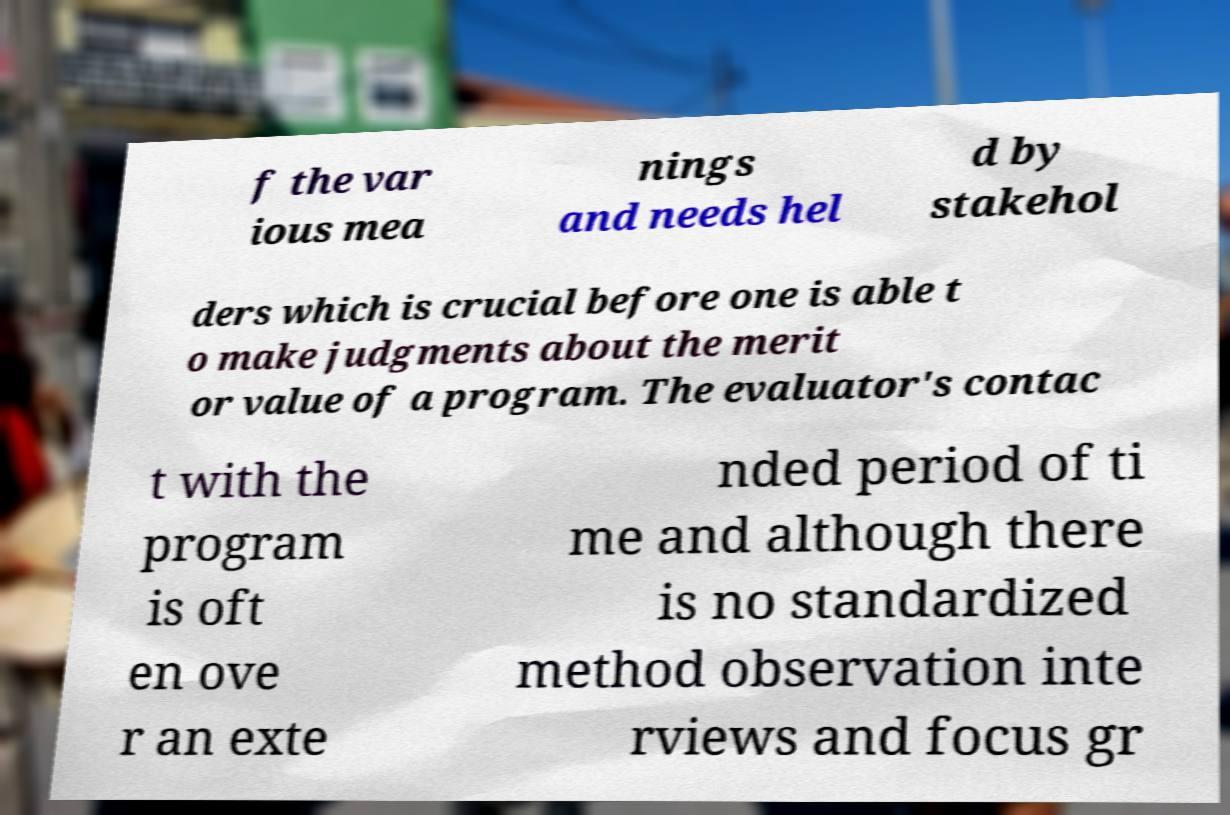I need the written content from this picture converted into text. Can you do that? f the var ious mea nings and needs hel d by stakehol ders which is crucial before one is able t o make judgments about the merit or value of a program. The evaluator's contac t with the program is oft en ove r an exte nded period of ti me and although there is no standardized method observation inte rviews and focus gr 